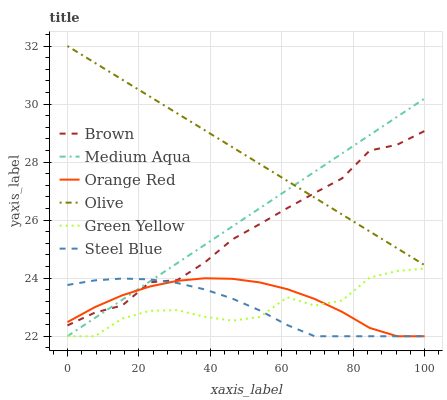Does Steel Blue have the minimum area under the curve?
Answer yes or no. Yes. Does Olive have the maximum area under the curve?
Answer yes or no. Yes. Does Medium Aqua have the minimum area under the curve?
Answer yes or no. No. Does Medium Aqua have the maximum area under the curve?
Answer yes or no. No. Is Olive the smoothest?
Answer yes or no. Yes. Is Green Yellow the roughest?
Answer yes or no. Yes. Is Steel Blue the smoothest?
Answer yes or no. No. Is Steel Blue the roughest?
Answer yes or no. No. Does Steel Blue have the lowest value?
Answer yes or no. Yes. Does Olive have the lowest value?
Answer yes or no. No. Does Olive have the highest value?
Answer yes or no. Yes. Does Medium Aqua have the highest value?
Answer yes or no. No. Is Green Yellow less than Olive?
Answer yes or no. Yes. Is Olive greater than Orange Red?
Answer yes or no. Yes. Does Olive intersect Brown?
Answer yes or no. Yes. Is Olive less than Brown?
Answer yes or no. No. Is Olive greater than Brown?
Answer yes or no. No. Does Green Yellow intersect Olive?
Answer yes or no. No. 